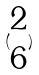Convert formula to latex. <formula><loc_0><loc_0><loc_500><loc_500>( \begin{matrix} 2 \\ 6 \end{matrix} )</formula> 